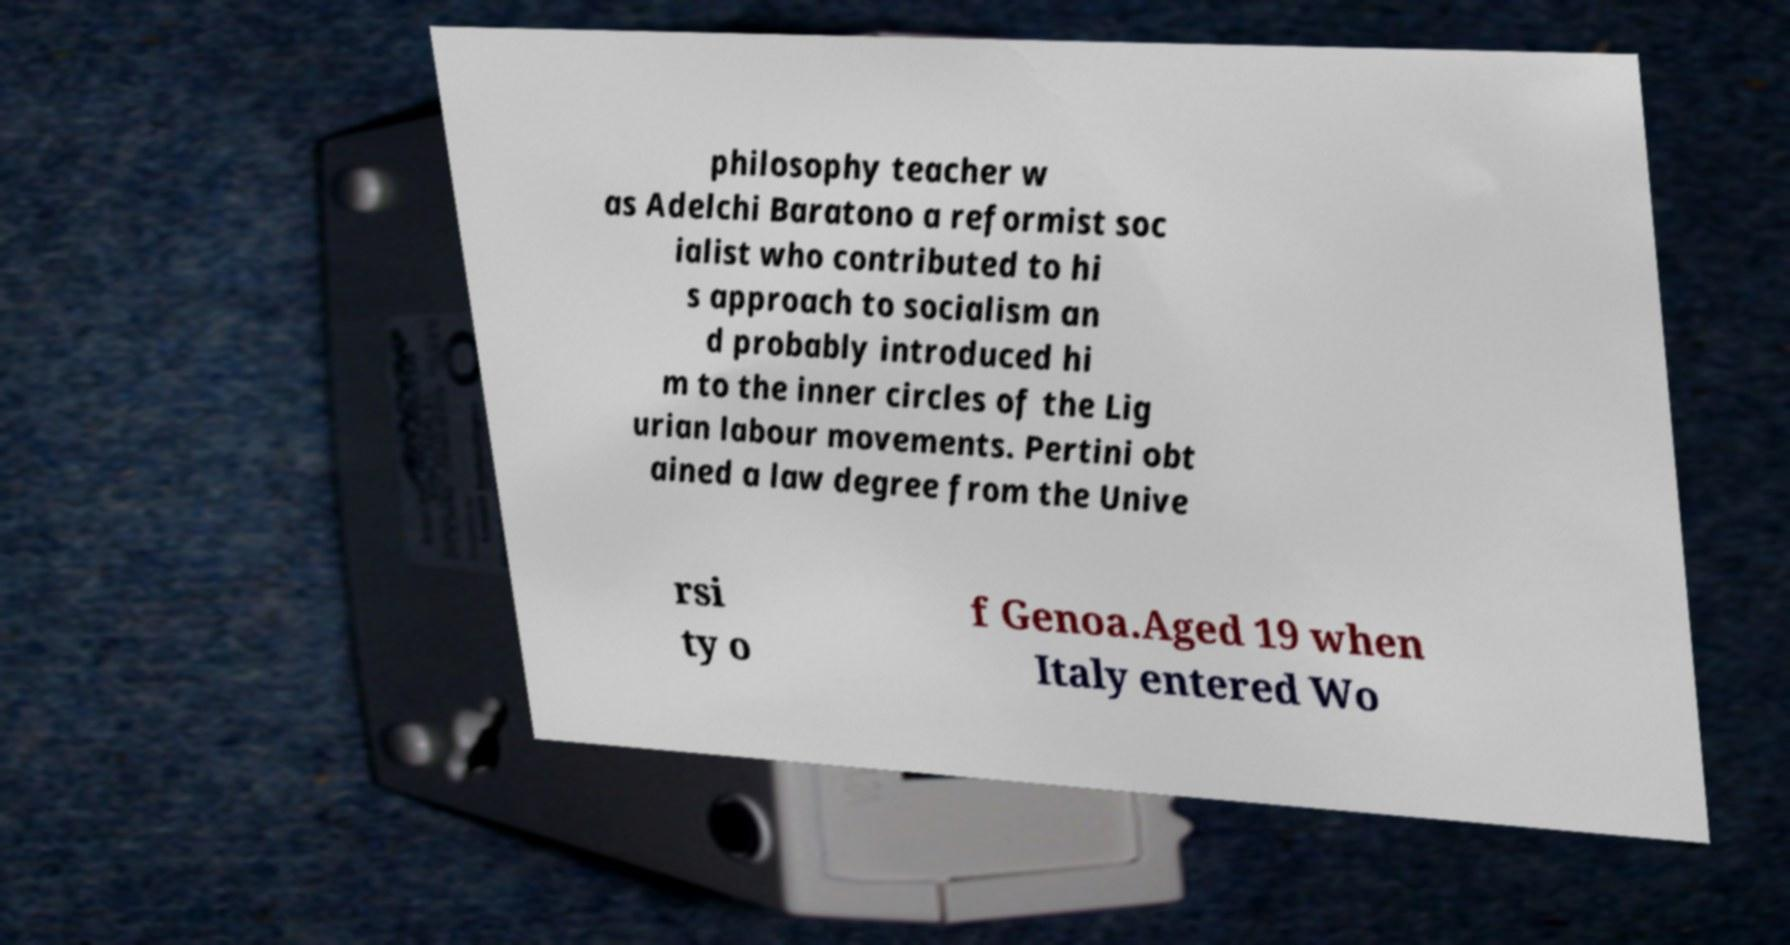Can you accurately transcribe the text from the provided image for me? philosophy teacher w as Adelchi Baratono a reformist soc ialist who contributed to hi s approach to socialism an d probably introduced hi m to the inner circles of the Lig urian labour movements. Pertini obt ained a law degree from the Unive rsi ty o f Genoa.Aged 19 when Italy entered Wo 